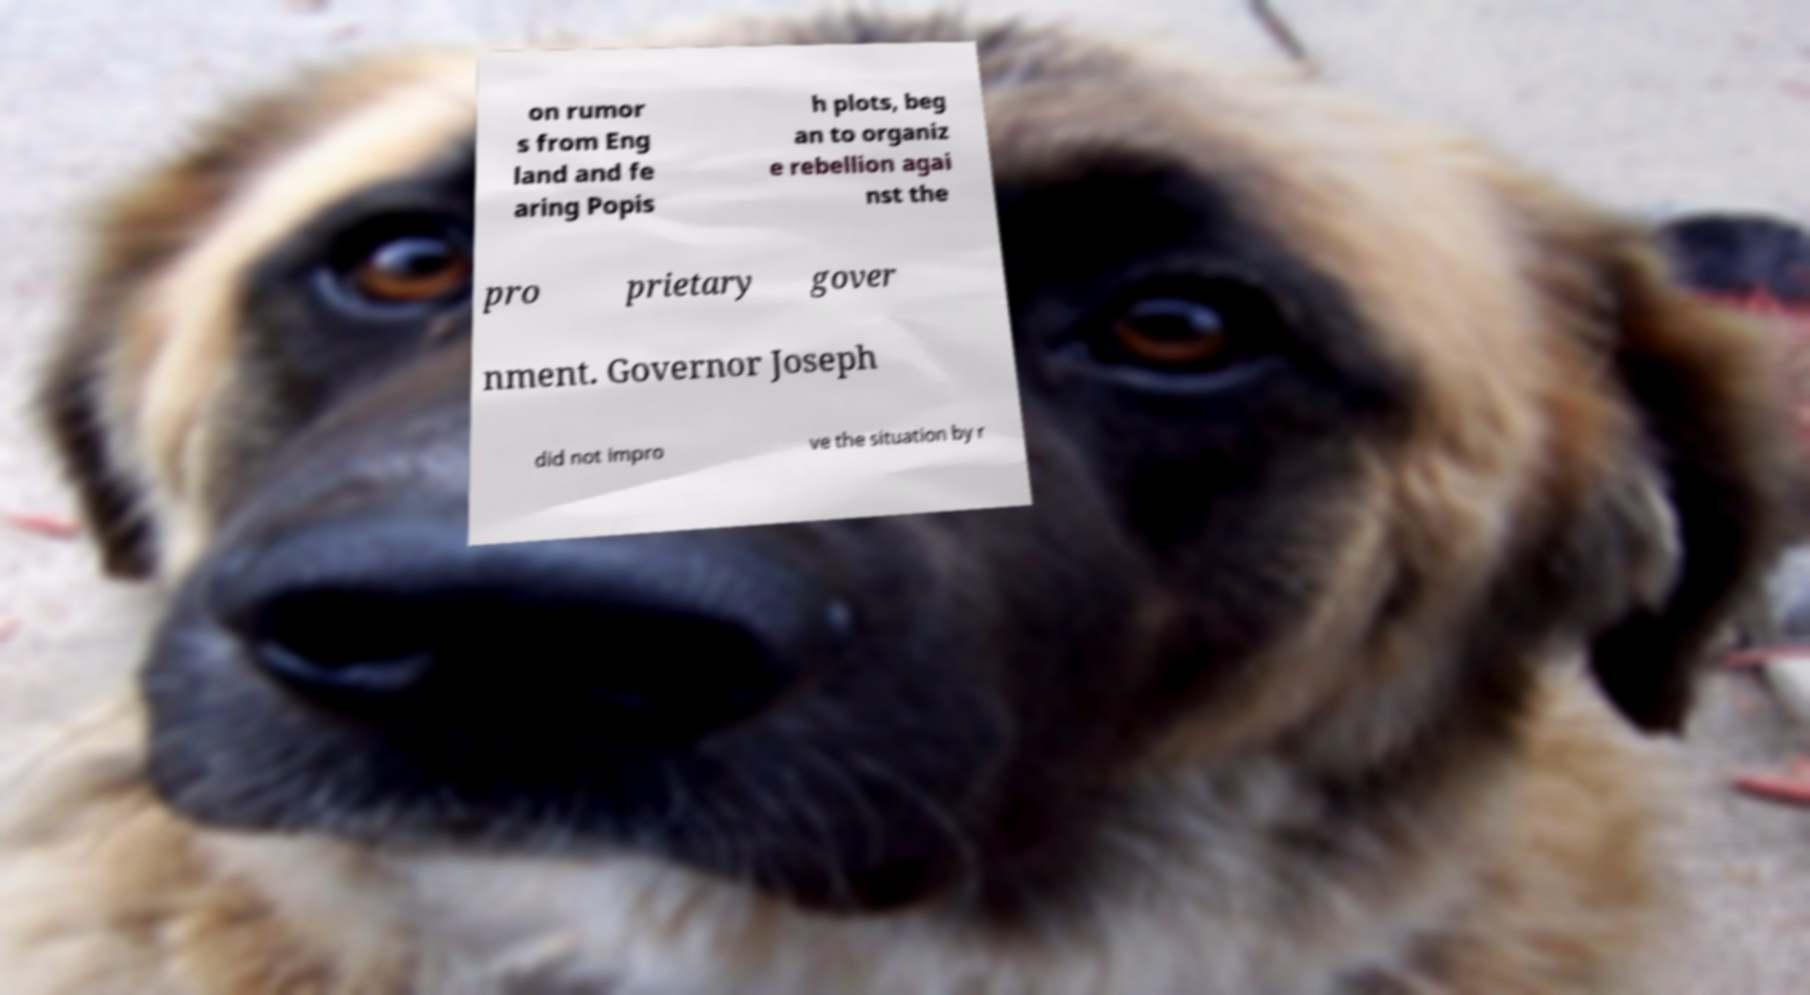Can you read and provide the text displayed in the image?This photo seems to have some interesting text. Can you extract and type it out for me? on rumor s from Eng land and fe aring Popis h plots, beg an to organiz e rebellion agai nst the pro prietary gover nment. Governor Joseph did not impro ve the situation by r 